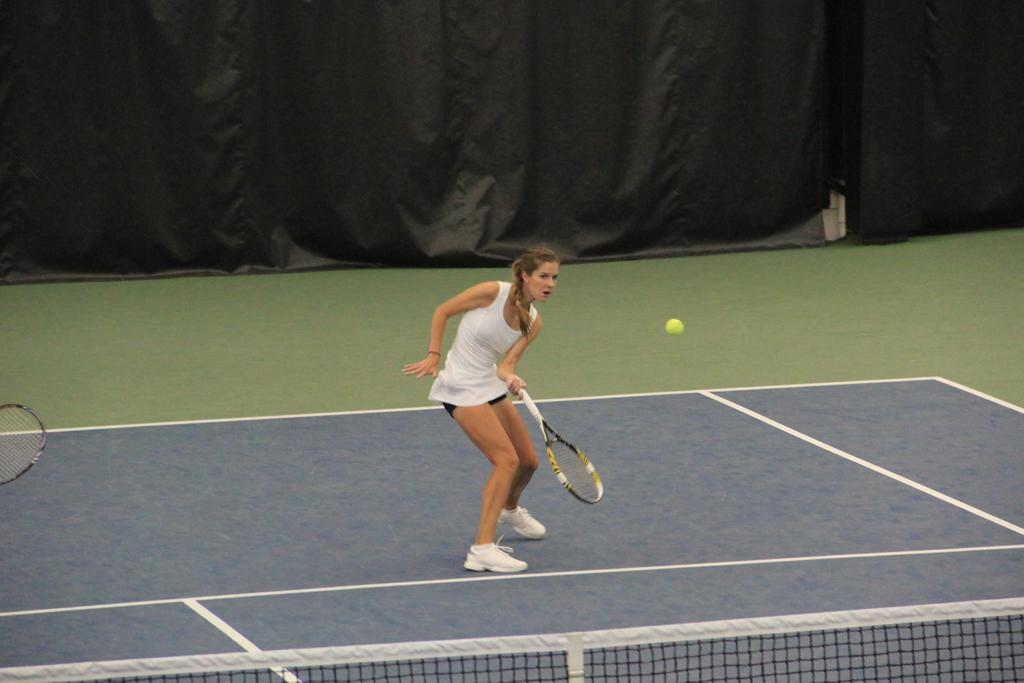Who is the main subject in the image? There is a woman in the image. What is the woman wearing? The woman is wearing a white dress and white shoes. What activity is the woman engaged in? The woman is playing with a shuttle. Where is the toothbrush located in the image? There is no toothbrush present in the image. What season is depicted in the image? The provided facts do not mention any seasonal details, so it cannot be determined from the image. 